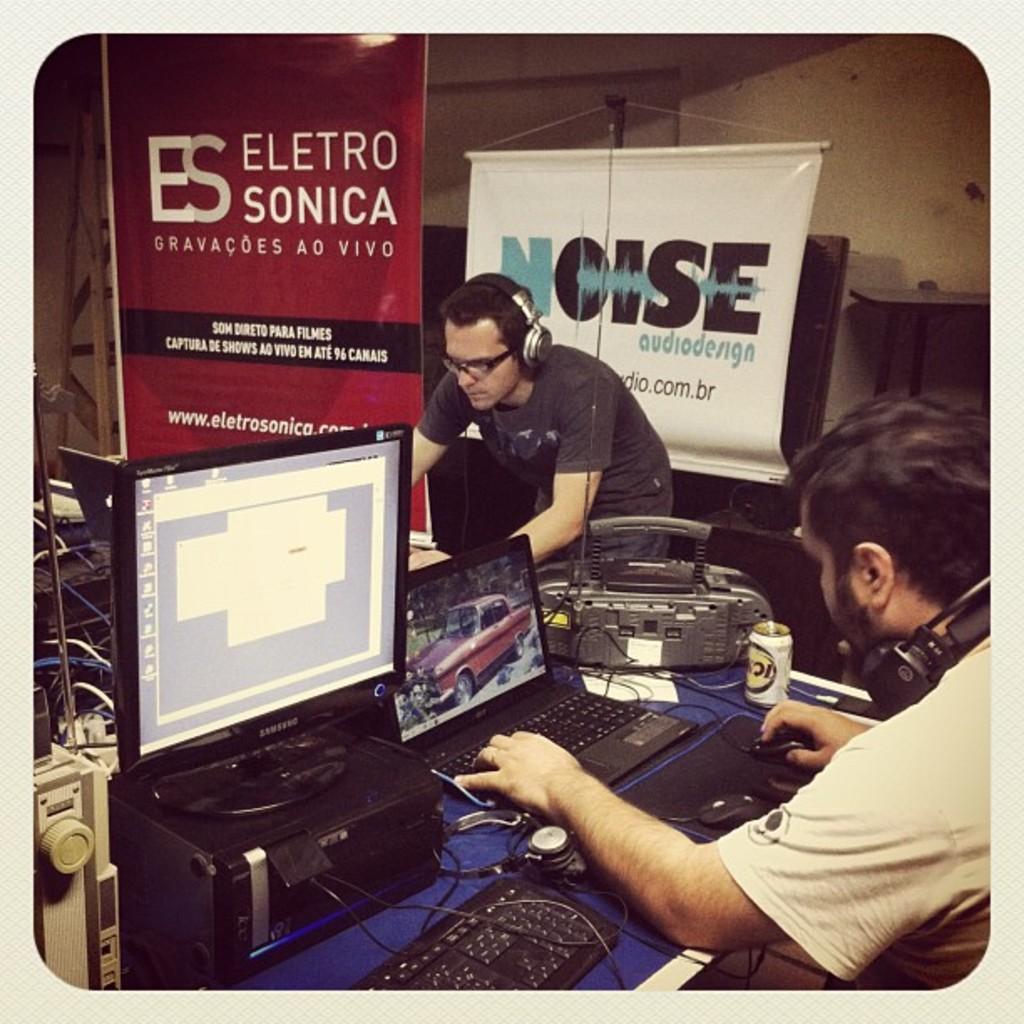What does the red poster say?
Your answer should be very brief. Electro sonica. What is the website on the red poster?
Give a very brief answer. Www.eletrosonica.com. 